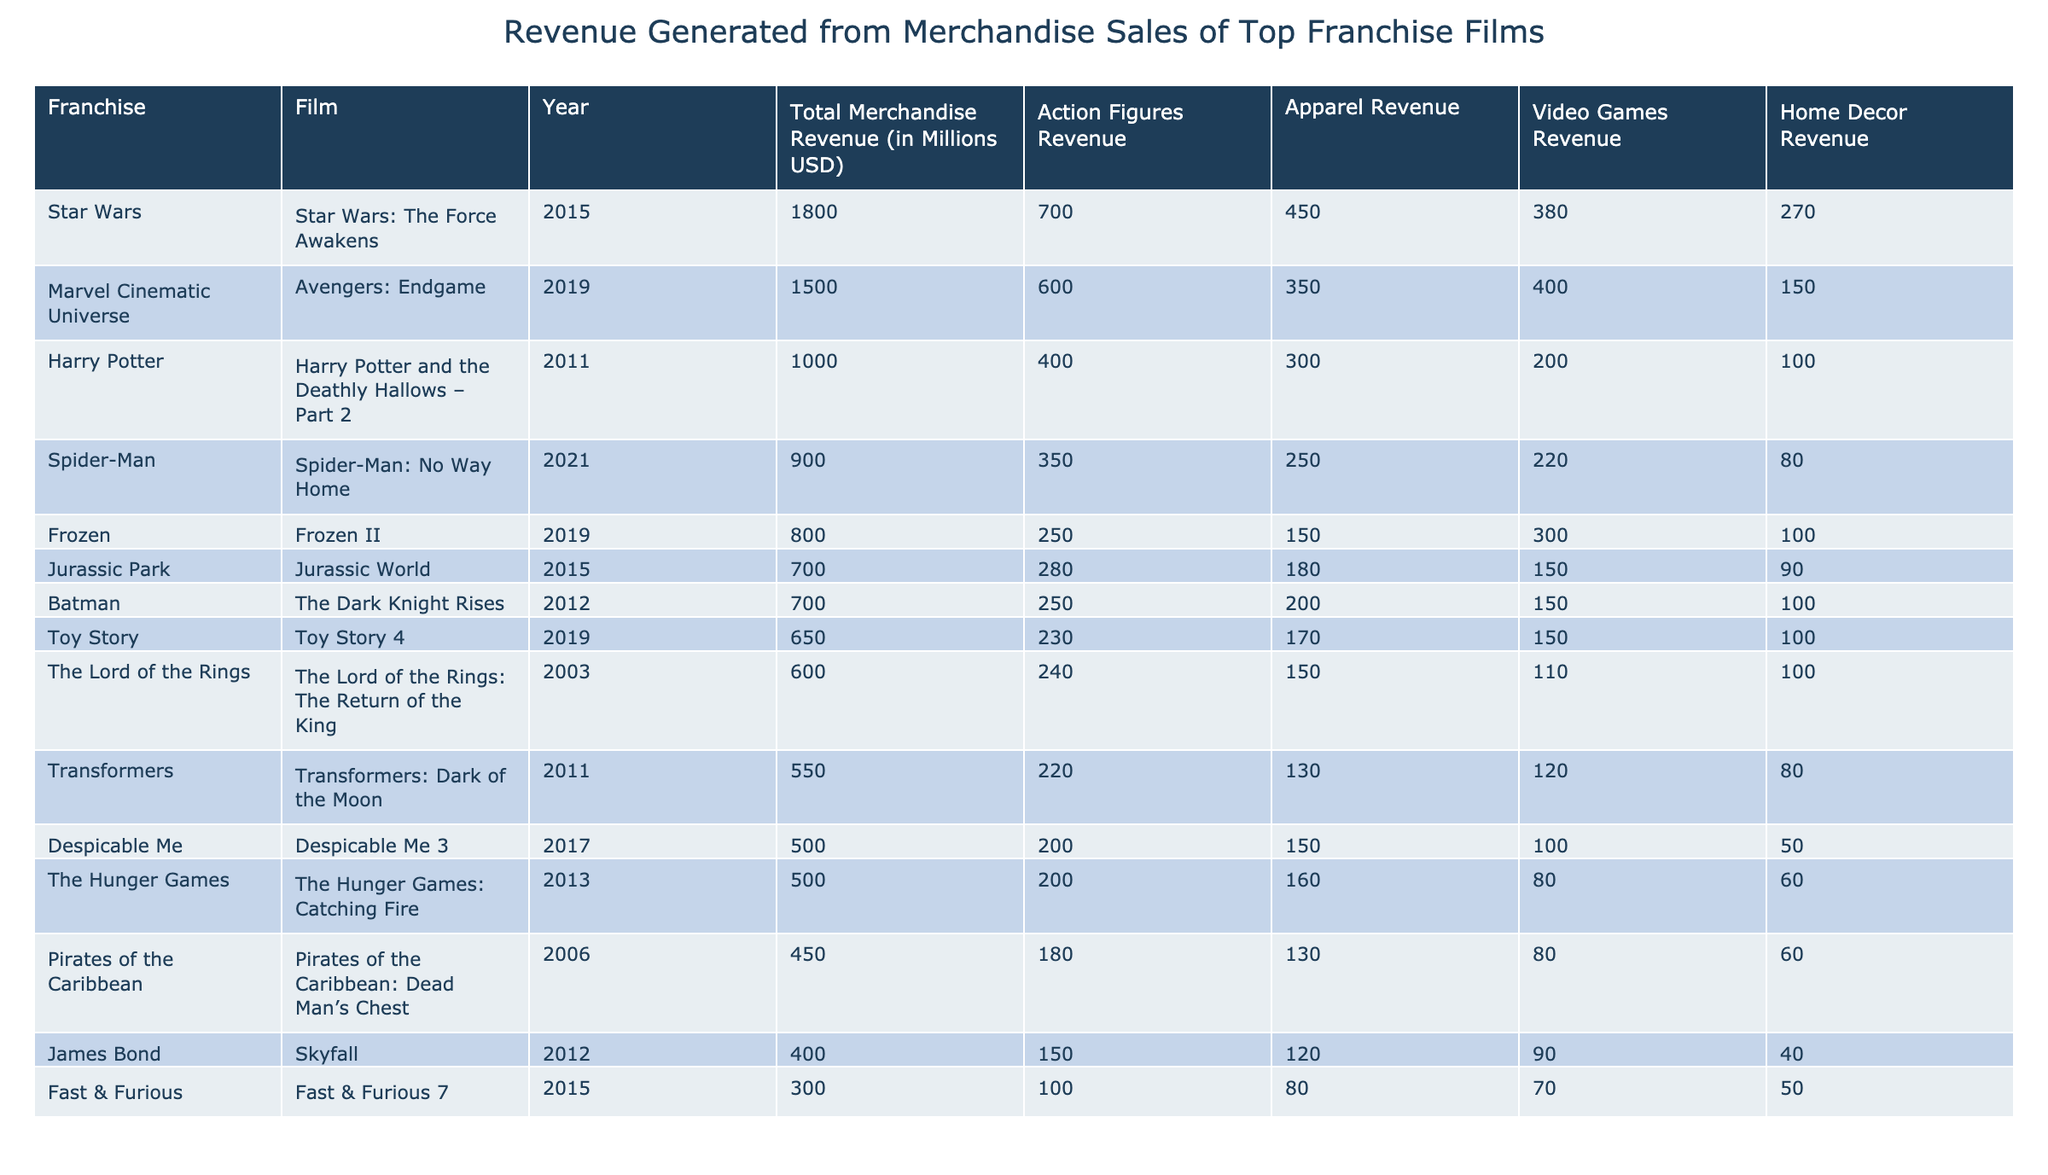What is the total merchandise revenue generated by the film Avengers: Endgame? The table shows that Avengers: Endgame generated a total merchandise revenue of 1500 million USD.
Answer: 1500 million USD Which film in the Star Wars franchise has the highest merchandise revenue? From the table, Star Wars: The Force Awakens has the highest merchandise revenue at 1800 million USD.
Answer: Star Wars: The Force Awakens What is the total revenue from action figures for Harry Potter and the Deathly Hallows – Part 2? The table indicates that the revenue generated from action figures for Harry Potter and the Deathly Hallows – Part 2 is 400 million USD.
Answer: 400 million USD What is the combined merchandise revenue from Toy Story 4 and Frozen II? For Toy Story 4, the merchandise revenue is 650 million USD, and for Frozen II, it is 800 million USD. The combined total is 650 + 800 = 1450 million USD.
Answer: 1450 million USD Is the revenue from apparel for Transformers: Dark of the Moon greater than that of Jurassic World? The table shows that Transformers: Dark of the Moon generated 130 million USD in apparel revenue, while Jurassic World generated 180 million USD. Since 130 is less than 180, the statement is false.
Answer: No Which franchise generated the least total merchandise revenue among the films listed? By examining the total merchandise revenue in the table, Despicable Me 3 has the least at 500 million USD compared to all other films listed.
Answer: Despicable Me 3 What is the average total merchandise revenue of all films in the table? The total merchandise revenue across all listed films sums up to 10,950 million USD. There are 11 films, so the average is 10,950 / 11 = 995.45 million USD.
Answer: 995.45 million USD How much more revenue was generated from video games than home decor for Spider-Man: No Way Home? The revenue from video games for Spider-Man: No Way Home is 220 million USD, and for home decor, it is 80 million USD. The difference is 220 - 80 = 140 million USD.
Answer: 140 million USD Was the revenue from action figures for Pirates of the Caribbean: Dead Man’s Chest equal to or greater than that of Fast & Furious 7? The revenue from action figures for Pirates of the Caribbean: Dead Man’s Chest is 180 million USD, while for Fast & Furious 7, it is 100 million USD. Since 180 is greater than 100, the statement is true.
Answer: Yes 